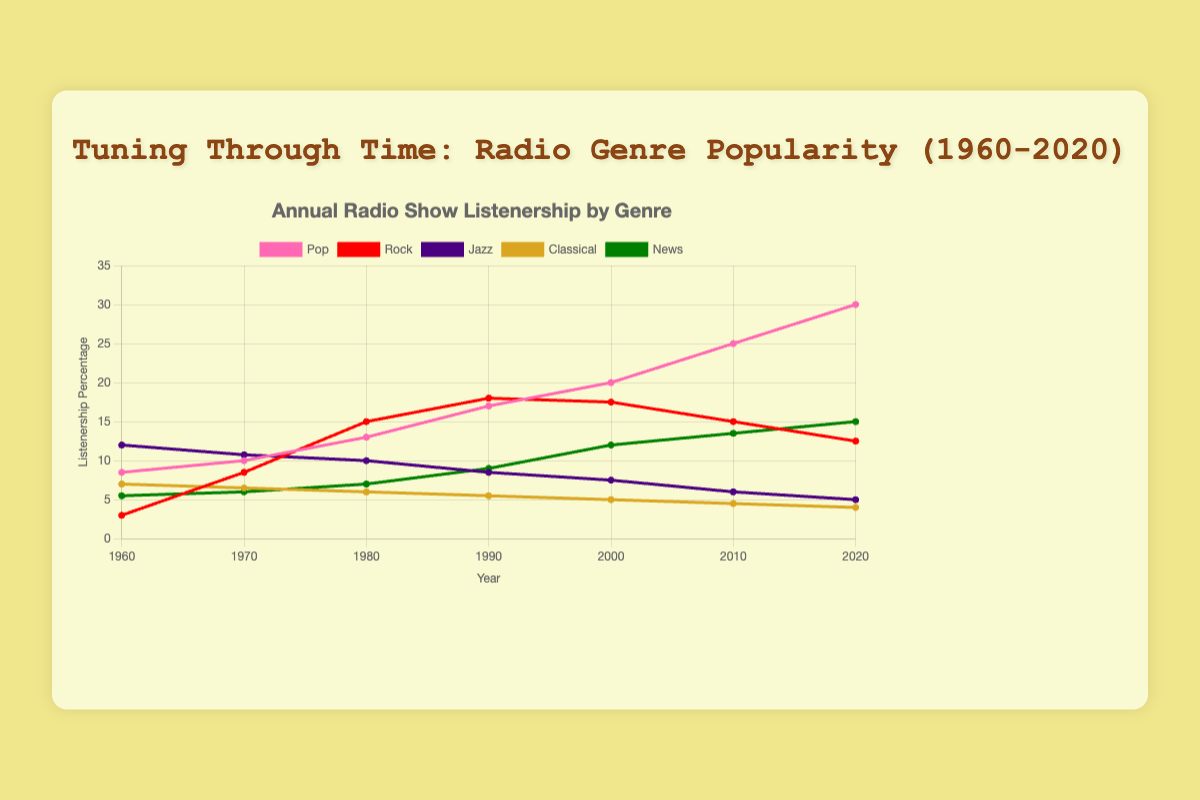Which genre had the highest percentage of listenership in 1980? To find the answer, we look at the data points for 1980. For Pop, it's 13%; for Rock, it's 15%; for Jazz, it's 10%; for Classical, it's 6%; and for News, it's 7%. The highest value is for Rock.
Answer: Rock What was the difference in listenership percentage between Pop and Jazz in 2020? For 2020, the listenership for Pop is 30% and for Jazz is 5%. The difference is \(30 - 5 = 25\).
Answer: 25 Which genre showed a continuous increase in listenership from 1960 to 2020? By observing the line plot or data points for each genre: Pop starts at 8.5% in 1960 and increases steadily to 30% in 2020. This continuous growth is unique to Pop.
Answer: Pop What is the average listenership for the News genre across all the years? To find the average, sum the listenership percentages for News (5.5+6+7+9+12+13.5+15) which totals 68, then divide by the number of data points (7 years): \(68 / 7 \approx 9.71\).
Answer: Approximately 9.71 Which genre had the sharpest decline in listenership from its peak to 2020? Jazz peaked at 12% in 1960 and declined to 5% in 2020. The decline is \(12 - 5 = 7\). Comparing this to other genres: none had a sharper decline.
Answer: Jazz In which decade did Rock surpass Pop in listenership? By looking at the intersecting points: in 1970, Rock (8.5%) is still lower than Pop (10%), but in 1980, Rock (15%) surpasses Pop (13%).
Answer: 1980s What is the total listenership difference between Pop and Classical across all years? Calculate the difference for each year and sum them: 
\( (8.5-7) + (10-6.5) + (13-6) + (17-5.5) + (20-5) + (25-4.5) + (30-4) \) = \(1.5 + 3.5 + 7 + 11.5 + 15 + 20.5 + 26\) = 85
Answer: 85 Which genres had higher listenership percentages than News in 1960? In 1960, News had 5.5%. Compare this to others: Pop (8.5%), Jazz (12%), and Classical (7%) are higher, while Rock (3%) is lower.
Answer: Pop, Jazz, Classical What is the ratio of listenership percentages between Pop and Rock in 2000? For Pop and Rock in 2000, the percentages are 20% and 17.5% respectively. The ratio is \(20 / 17.5 = 1.14\).
Answer: 1.14 Which genre had the most steady decline from 1960 to 2020? Observing the consistent downward trend: Classical starts at 7% in 1960 and gently declines to 4% in 2020 without major fluctuations.
Answer: Classical 